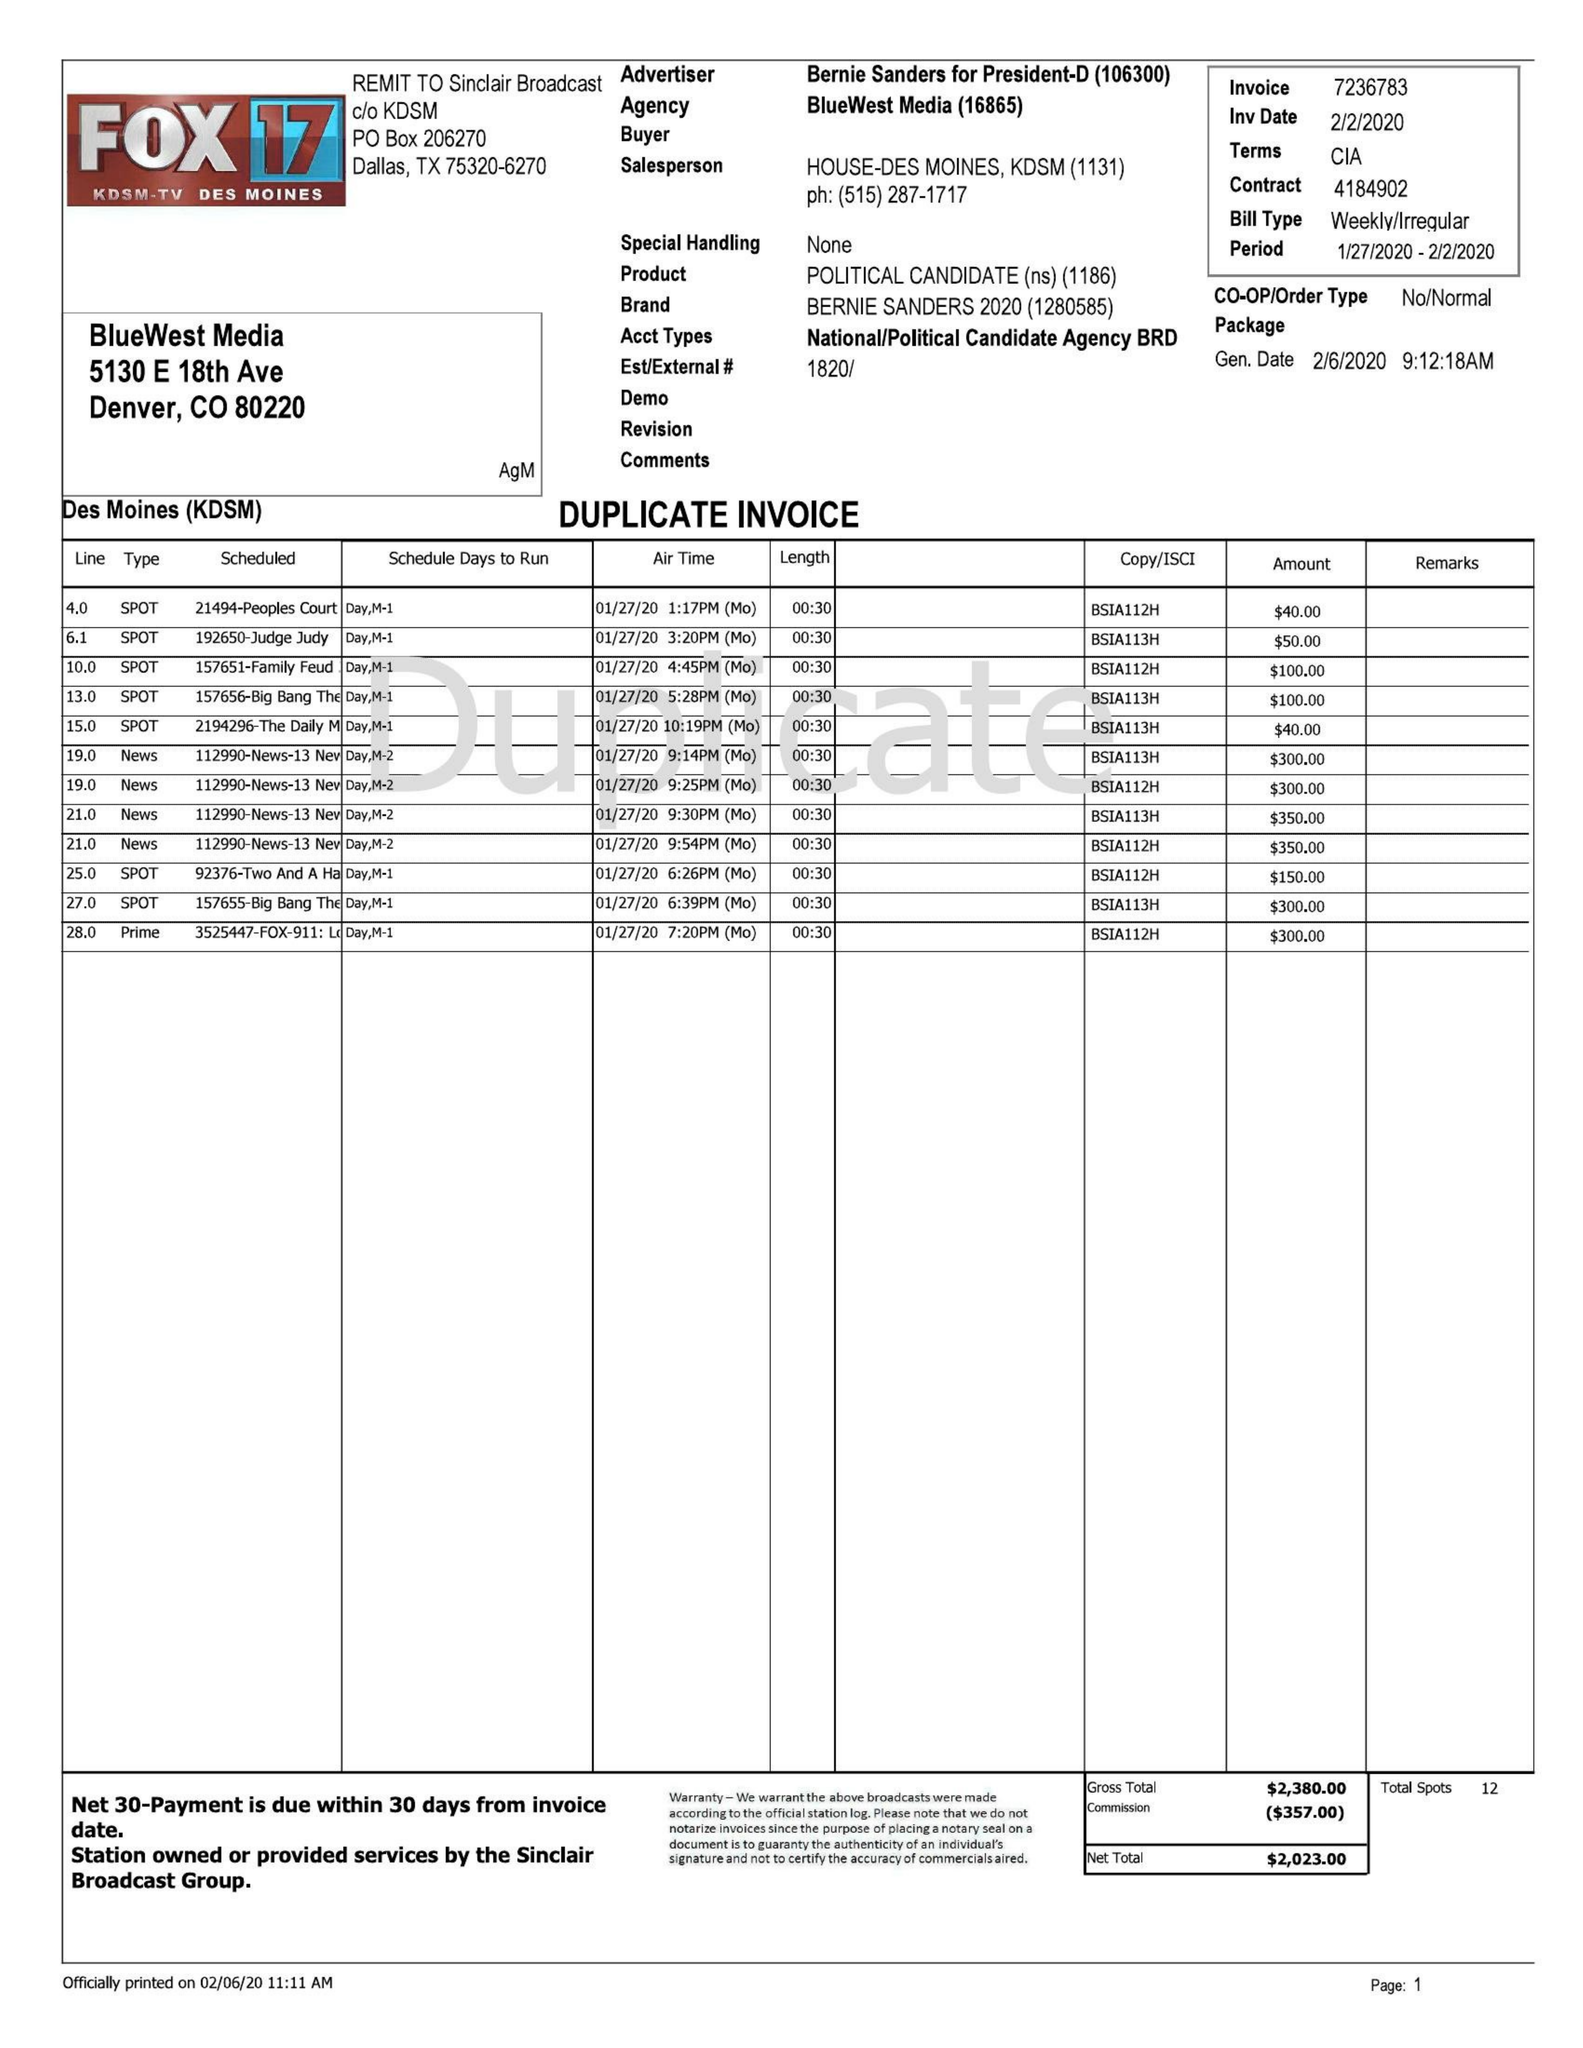What is the value for the contract_num?
Answer the question using a single word or phrase. 7236783 